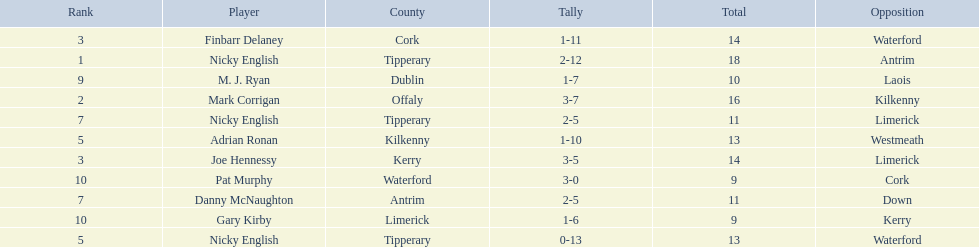What was the combined total of nicky english and mark corrigan? 34. 